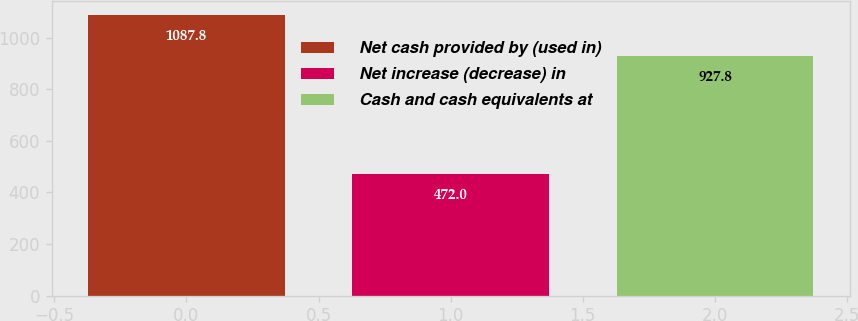Convert chart. <chart><loc_0><loc_0><loc_500><loc_500><bar_chart><fcel>Net cash provided by (used in)<fcel>Net increase (decrease) in<fcel>Cash and cash equivalents at<nl><fcel>1087.8<fcel>472<fcel>927.8<nl></chart> 